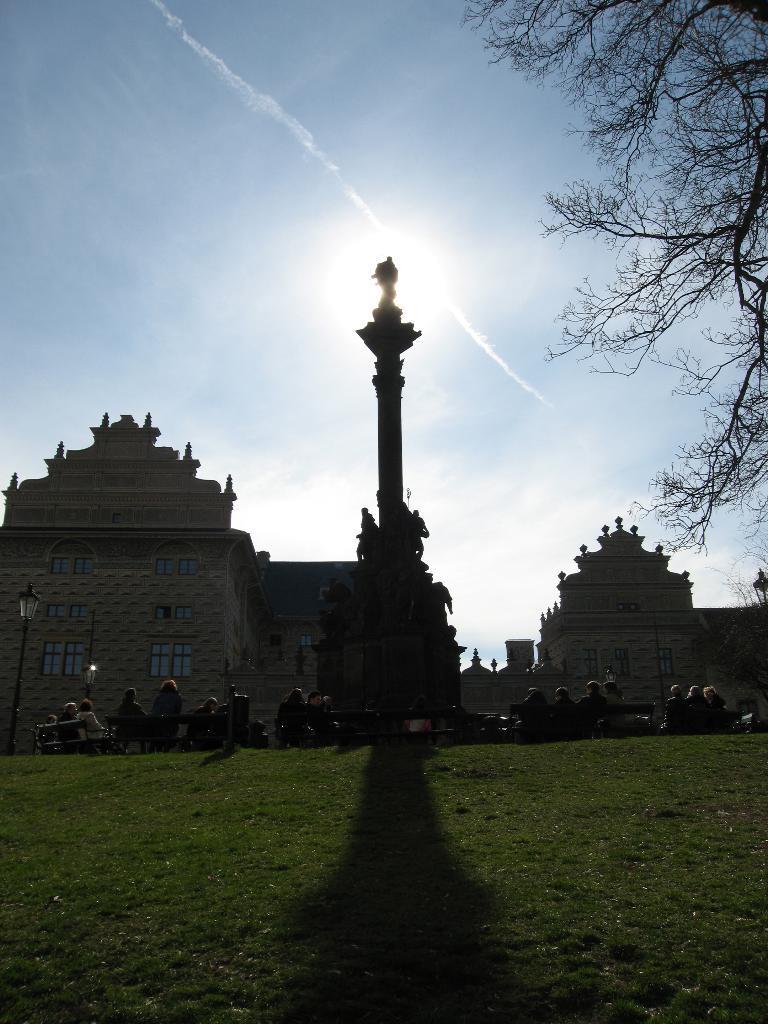In one or two sentences, can you explain what this image depicts? At the bottom of the image there is grass. There are people sitting on benches. In the center of the image there is a statue. In the background of the image there are buildings. To the right side of the image there is a tree. At the top of the image there is sky. 